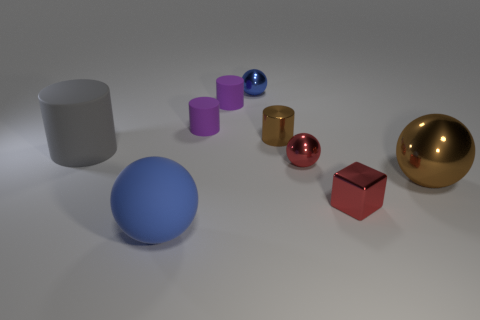Is the small metal cylinder the same color as the large metallic thing?
Your answer should be very brief. Yes. Are there fewer shiny balls that are on the right side of the red cube than small purple matte cylinders?
Give a very brief answer. Yes. Is the gray cylinder made of the same material as the large blue thing?
Ensure brevity in your answer.  Yes. How many spheres have the same material as the small brown cylinder?
Your response must be concise. 3. What color is the sphere that is the same material as the big gray cylinder?
Ensure brevity in your answer.  Blue. The tiny brown object is what shape?
Keep it short and to the point. Cylinder. What material is the blue ball in front of the gray matte cylinder?
Offer a very short reply. Rubber. Are there any cylinders that have the same color as the big metal thing?
Your answer should be very brief. Yes. The brown object that is the same size as the red shiny cube is what shape?
Make the answer very short. Cylinder. The big matte object that is in front of the gray rubber object is what color?
Your response must be concise. Blue. 